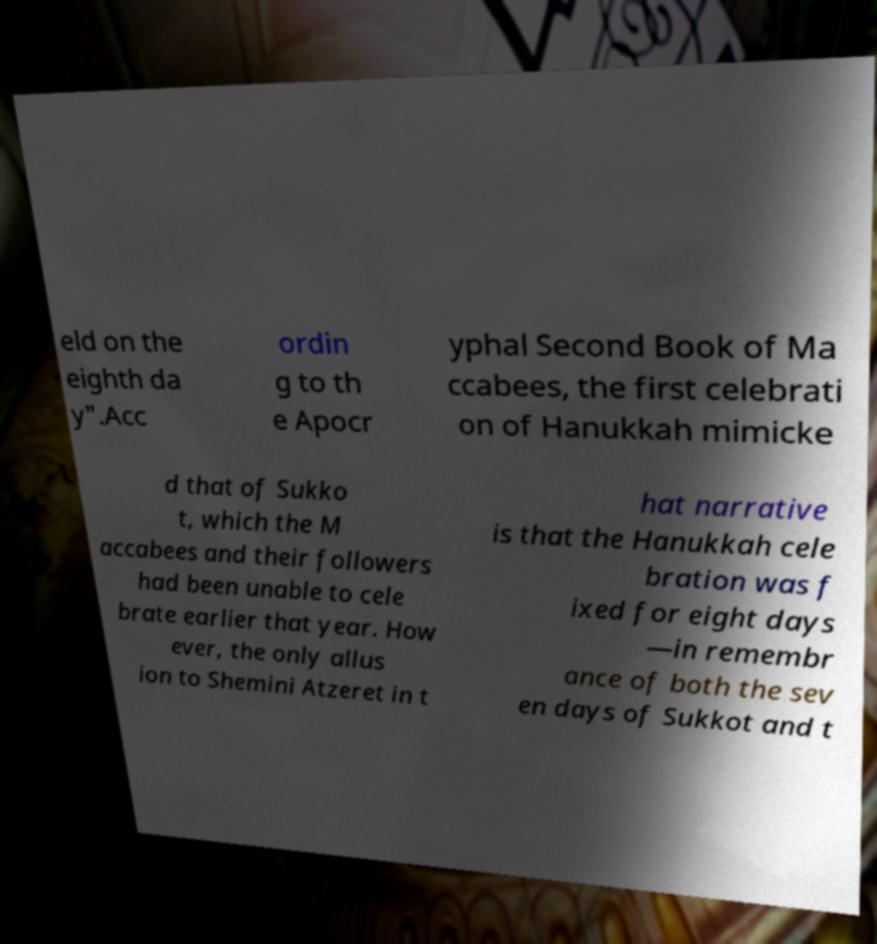I need the written content from this picture converted into text. Can you do that? eld on the eighth da y".Acc ordin g to th e Apocr yphal Second Book of Ma ccabees, the first celebrati on of Hanukkah mimicke d that of Sukko t, which the M accabees and their followers had been unable to cele brate earlier that year. How ever, the only allus ion to Shemini Atzeret in t hat narrative is that the Hanukkah cele bration was f ixed for eight days —in remembr ance of both the sev en days of Sukkot and t 